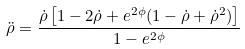Convert formula to latex. <formula><loc_0><loc_0><loc_500><loc_500>\ddot { \rho } = \frac { \dot { \rho } \left [ 1 - 2 \dot { \rho } + e ^ { 2 \phi } ( 1 - \dot { \rho } + \dot { \rho } ^ { 2 } ) \right ] } { 1 - e ^ { 2 \phi } }</formula> 